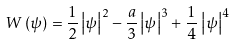Convert formula to latex. <formula><loc_0><loc_0><loc_500><loc_500>W \left ( \psi \right ) = \frac { 1 } { 2 } \left | \psi \right | ^ { 2 } - \frac { a } { 3 } \left | \psi \right | ^ { 3 } + \frac { 1 } { 4 } \, \left | \psi \right | ^ { 4 }</formula> 